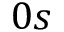<formula> <loc_0><loc_0><loc_500><loc_500>0 s</formula> 